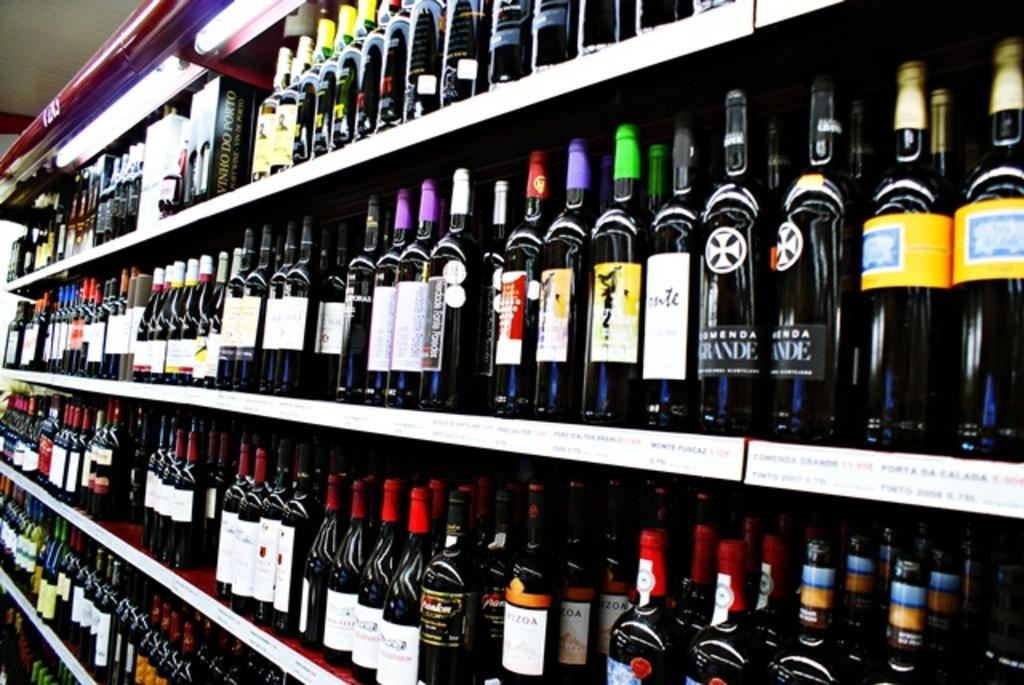<image>
Relay a brief, clear account of the picture shown. Wine bottles line a shelf, including one with a label that reads Grande. 